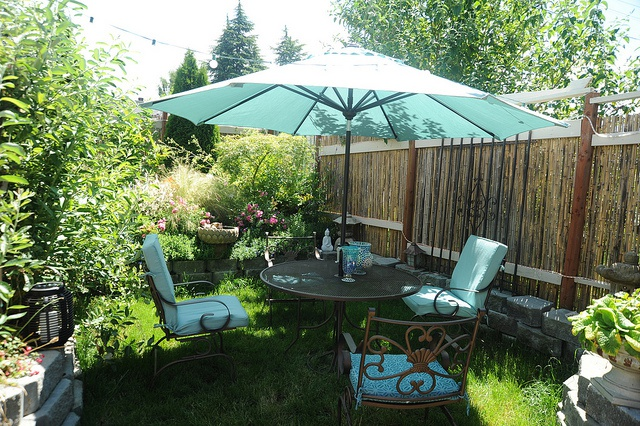Describe the objects in this image and their specific colors. I can see umbrella in beige, turquoise, white, and teal tones, chair in beige, black, and teal tones, chair in beige, black, and teal tones, potted plant in beige, gray, and darkgreen tones, and dining table in beige, black, purple, and teal tones in this image. 